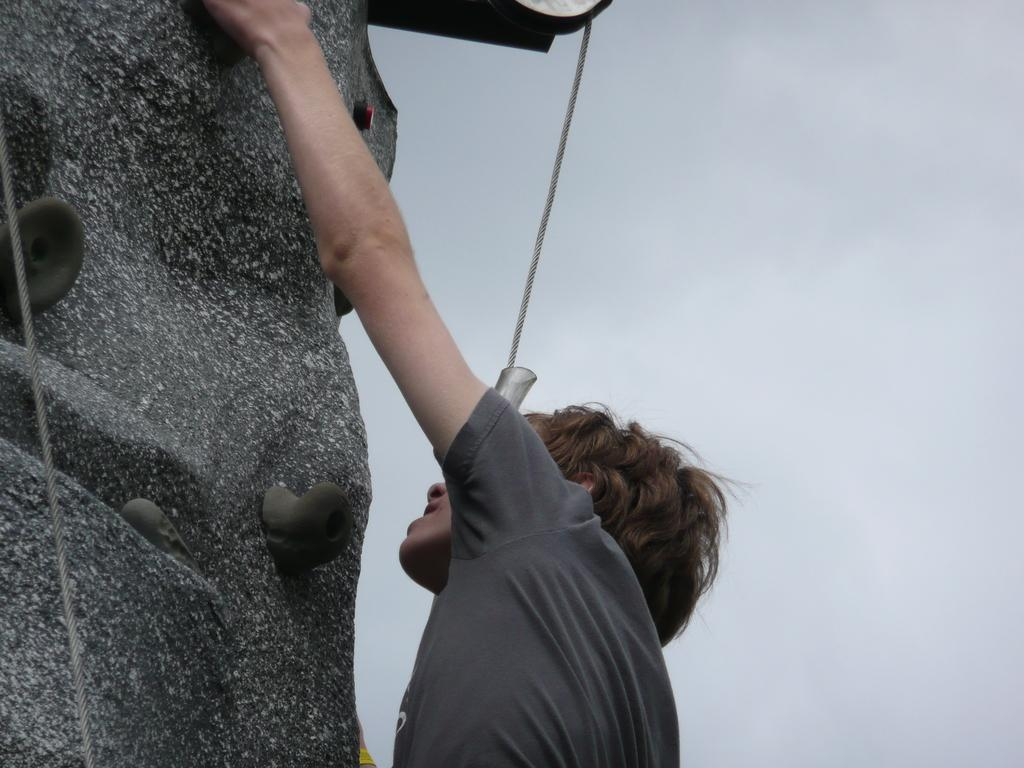Who or what is in the image? There is a person in the image. What is the person wearing? The person is wearing a black t-shirt. What activity is the person engaged in? The person is climbing a rock. What is the person using to assist with the climb? There is a rope in the image that the person might be using. What can be seen in the sky in the image? Clouds are visible at the top of the image. What rule is being enforced by the snow in the image? There is no snow present in the image, so no rule can be enforced by it. How does the size of the person compare to the size of the rock in the image? The provided facts do not include information about the size of the person or the rock, so it cannot be determined how they compare in size. 